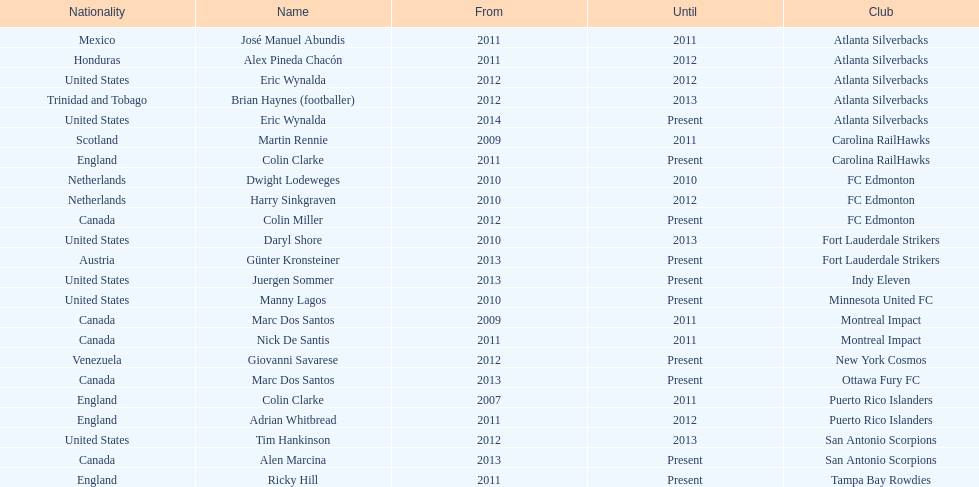What name is listed at the top? José Manuel Abundis. Would you be able to parse every entry in this table? {'header': ['Nationality', 'Name', 'From', 'Until', 'Club'], 'rows': [['Mexico', 'José Manuel Abundis', '2011', '2011', 'Atlanta Silverbacks'], ['Honduras', 'Alex Pineda Chacón', '2011', '2012', 'Atlanta Silverbacks'], ['United States', 'Eric Wynalda', '2012', '2012', 'Atlanta Silverbacks'], ['Trinidad and Tobago', 'Brian Haynes (footballer)', '2012', '2013', 'Atlanta Silverbacks'], ['United States', 'Eric Wynalda', '2014', 'Present', 'Atlanta Silverbacks'], ['Scotland', 'Martin Rennie', '2009', '2011', 'Carolina RailHawks'], ['England', 'Colin Clarke', '2011', 'Present', 'Carolina RailHawks'], ['Netherlands', 'Dwight Lodeweges', '2010', '2010', 'FC Edmonton'], ['Netherlands', 'Harry Sinkgraven', '2010', '2012', 'FC Edmonton'], ['Canada', 'Colin Miller', '2012', 'Present', 'FC Edmonton'], ['United States', 'Daryl Shore', '2010', '2013', 'Fort Lauderdale Strikers'], ['Austria', 'Günter Kronsteiner', '2013', 'Present', 'Fort Lauderdale Strikers'], ['United States', 'Juergen Sommer', '2013', 'Present', 'Indy Eleven'], ['United States', 'Manny Lagos', '2010', 'Present', 'Minnesota United FC'], ['Canada', 'Marc Dos Santos', '2009', '2011', 'Montreal Impact'], ['Canada', 'Nick De Santis', '2011', '2011', 'Montreal Impact'], ['Venezuela', 'Giovanni Savarese', '2012', 'Present', 'New York Cosmos'], ['Canada', 'Marc Dos Santos', '2013', 'Present', 'Ottawa Fury FC'], ['England', 'Colin Clarke', '2007', '2011', 'Puerto Rico Islanders'], ['England', 'Adrian Whitbread', '2011', '2012', 'Puerto Rico Islanders'], ['United States', 'Tim Hankinson', '2012', '2013', 'San Antonio Scorpions'], ['Canada', 'Alen Marcina', '2013', 'Present', 'San Antonio Scorpions'], ['England', 'Ricky Hill', '2011', 'Present', 'Tampa Bay Rowdies']]} 